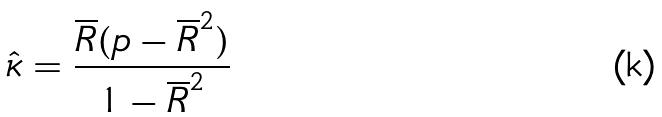<formula> <loc_0><loc_0><loc_500><loc_500>\hat { \kappa } = \frac { \overline { R } ( p - \overline { R } ^ { 2 } ) } { 1 - \overline { R } ^ { 2 } }</formula> 